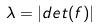Convert formula to latex. <formula><loc_0><loc_0><loc_500><loc_500>\lambda = | d e t ( f ) |</formula> 